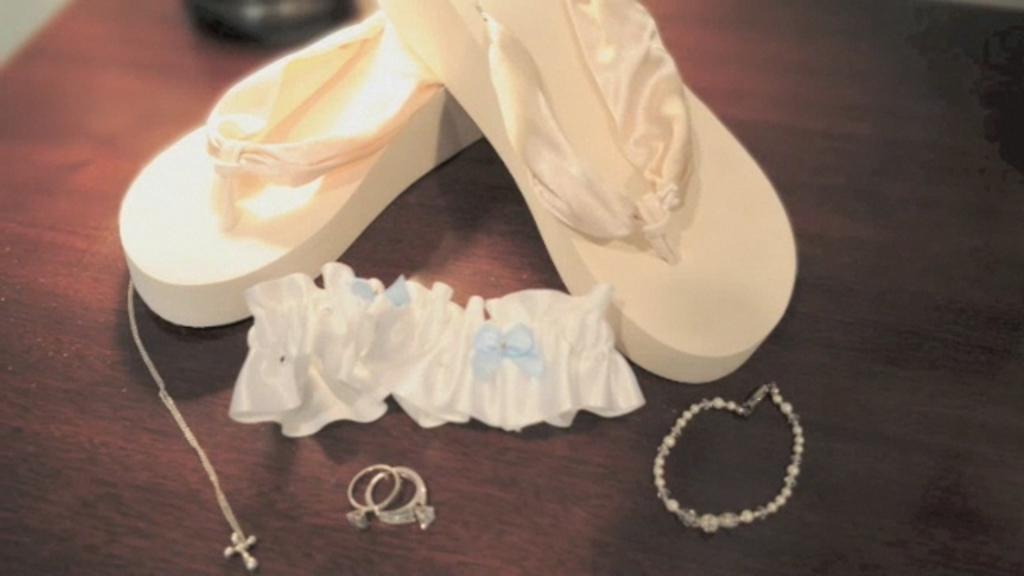Please provide a concise description of this image. In this image I can see the white color footwear, rings, chain, bracelet and the cloth on the brown color surface. 